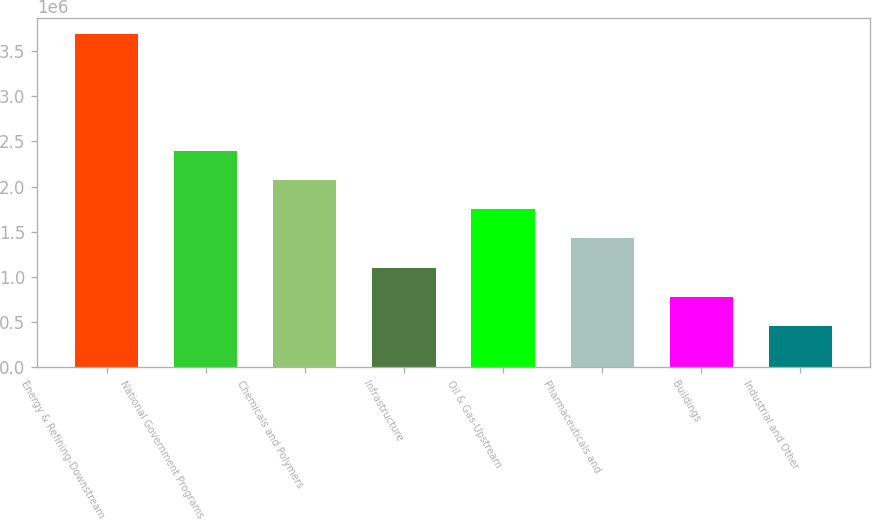Convert chart. <chart><loc_0><loc_0><loc_500><loc_500><bar_chart><fcel>Energy & Refining-Downstream<fcel>National Government Programs<fcel>Chemicals and Polymers<fcel>Infrastructure<fcel>Oil & Gas-Upstream<fcel>Pharmaceuticals and<fcel>Buildings<fcel>Industrial and Other<nl><fcel>3.6878e+06<fcel>2.39399e+06<fcel>2.07054e+06<fcel>1.10019e+06<fcel>1.74709e+06<fcel>1.42364e+06<fcel>776736<fcel>453285<nl></chart> 